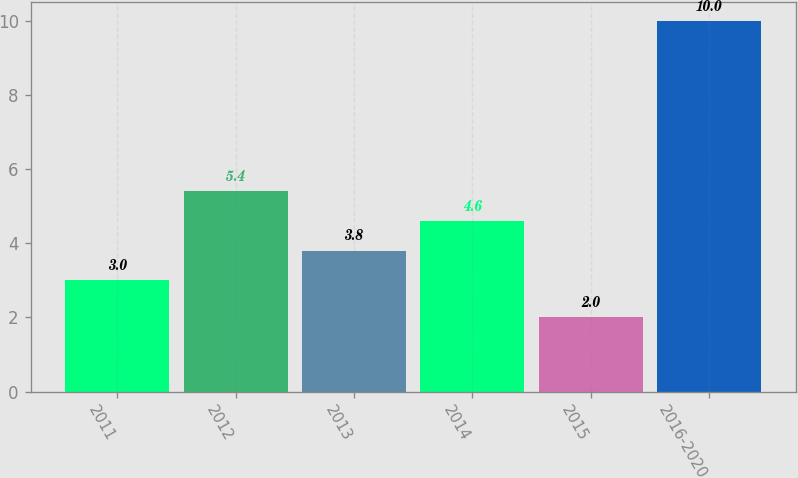Convert chart. <chart><loc_0><loc_0><loc_500><loc_500><bar_chart><fcel>2011<fcel>2012<fcel>2013<fcel>2014<fcel>2015<fcel>2016-2020<nl><fcel>3<fcel>5.4<fcel>3.8<fcel>4.6<fcel>2<fcel>10<nl></chart> 